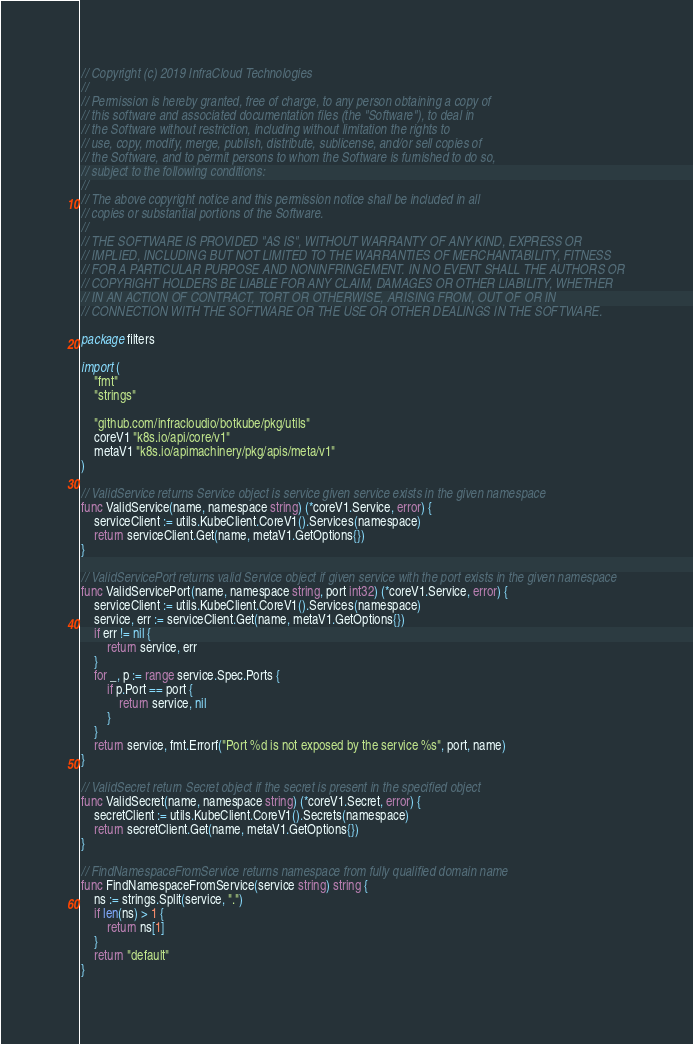<code> <loc_0><loc_0><loc_500><loc_500><_Go_>// Copyright (c) 2019 InfraCloud Technologies
//
// Permission is hereby granted, free of charge, to any person obtaining a copy of
// this software and associated documentation files (the "Software"), to deal in
// the Software without restriction, including without limitation the rights to
// use, copy, modify, merge, publish, distribute, sublicense, and/or sell copies of
// the Software, and to permit persons to whom the Software is furnished to do so,
// subject to the following conditions:
//
// The above copyright notice and this permission notice shall be included in all
// copies or substantial portions of the Software.
//
// THE SOFTWARE IS PROVIDED "AS IS", WITHOUT WARRANTY OF ANY KIND, EXPRESS OR
// IMPLIED, INCLUDING BUT NOT LIMITED TO THE WARRANTIES OF MERCHANTABILITY, FITNESS
// FOR A PARTICULAR PURPOSE AND NONINFRINGEMENT. IN NO EVENT SHALL THE AUTHORS OR
// COPYRIGHT HOLDERS BE LIABLE FOR ANY CLAIM, DAMAGES OR OTHER LIABILITY, WHETHER
// IN AN ACTION OF CONTRACT, TORT OR OTHERWISE, ARISING FROM, OUT OF OR IN
// CONNECTION WITH THE SOFTWARE OR THE USE OR OTHER DEALINGS IN THE SOFTWARE.

package filters

import (
	"fmt"
	"strings"

	"github.com/infracloudio/botkube/pkg/utils"
	coreV1 "k8s.io/api/core/v1"
	metaV1 "k8s.io/apimachinery/pkg/apis/meta/v1"
)

// ValidService returns Service object is service given service exists in the given namespace
func ValidService(name, namespace string) (*coreV1.Service, error) {
	serviceClient := utils.KubeClient.CoreV1().Services(namespace)
	return serviceClient.Get(name, metaV1.GetOptions{})
}

// ValidServicePort returns valid Service object if given service with the port exists in the given namespace
func ValidServicePort(name, namespace string, port int32) (*coreV1.Service, error) {
	serviceClient := utils.KubeClient.CoreV1().Services(namespace)
	service, err := serviceClient.Get(name, metaV1.GetOptions{})
	if err != nil {
		return service, err
	}
	for _, p := range service.Spec.Ports {
		if p.Port == port {
			return service, nil
		}
	}
	return service, fmt.Errorf("Port %d is not exposed by the service %s", port, name)
}

// ValidSecret return Secret object if the secret is present in the specified object
func ValidSecret(name, namespace string) (*coreV1.Secret, error) {
	secretClient := utils.KubeClient.CoreV1().Secrets(namespace)
	return secretClient.Get(name, metaV1.GetOptions{})
}

// FindNamespaceFromService returns namespace from fully qualified domain name
func FindNamespaceFromService(service string) string {
	ns := strings.Split(service, ".")
	if len(ns) > 1 {
		return ns[1]
	}
	return "default"
}
</code> 